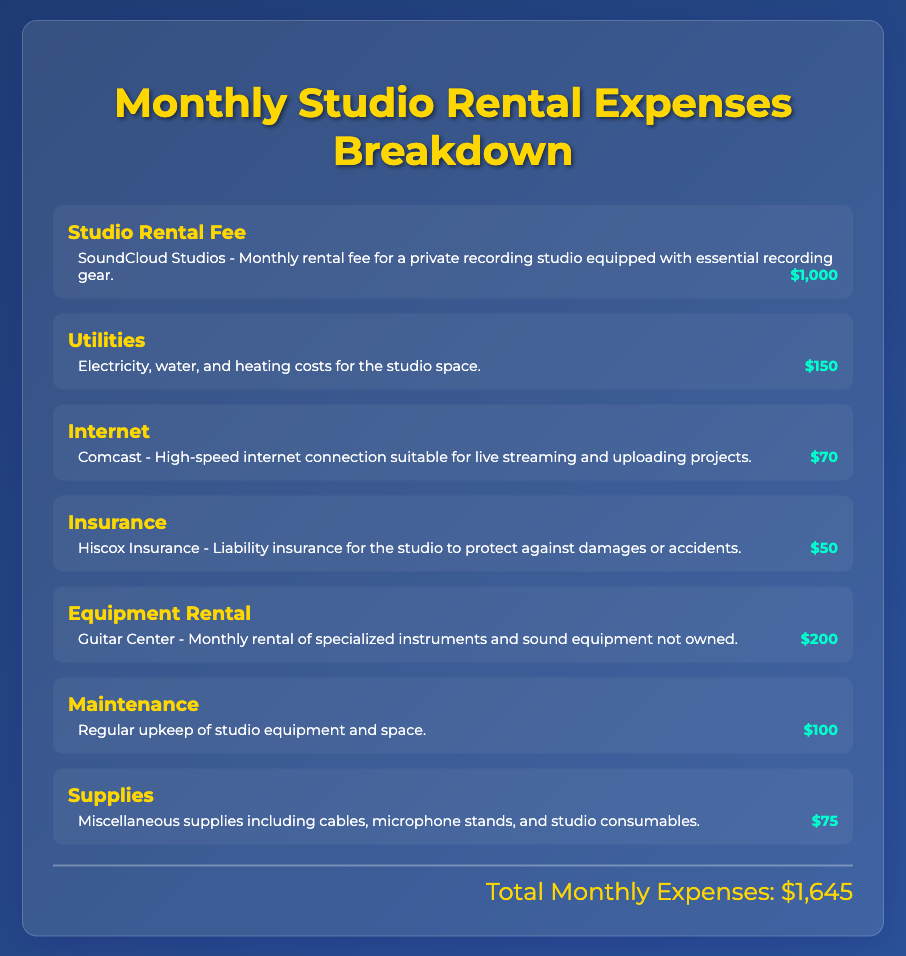What is the studio rental fee? The studio rental fee is specifically mentioned as $1,000 in the document.
Answer: $1,000 How much do utilities cost? The document indicates that utilities cost $150 per month for electricity, water, and heating.
Answer: $150 What is the monthly expense for internet? The document specifies that the internet expense is $70 for high-speed connectivity.
Answer: $70 What type of insurance is included in the expenses? The document states that the insurance is liability insurance to protect against damages or accidents.
Answer: Liability insurance How much does equipment rental cost? The document notes that equipment rental from Guitar Center costs $200 per month.
Answer: $200 What is the total monthly expense? The total monthly expenses are calculated at $1,645 based on the sum of all listed items.
Answer: $1,645 Which company provides the internet service? The document mentions Comcast as the provider of the high-speed internet connection.
Answer: Comcast What do the supplies include? The supplies mentioned in the document refer to miscellaneous items like cables and microphone stands.
Answer: Miscellaneous supplies What is covered under maintenance expenses? The maintenance expenses consist of the regular upkeep of studio equipment and space as described in the document.
Answer: Regular upkeep What is the purpose of the studio insurance? The document explains the insurance's purpose is to protect against damages or accidents occurring in the studio.
Answer: Protect against damages or accidents 